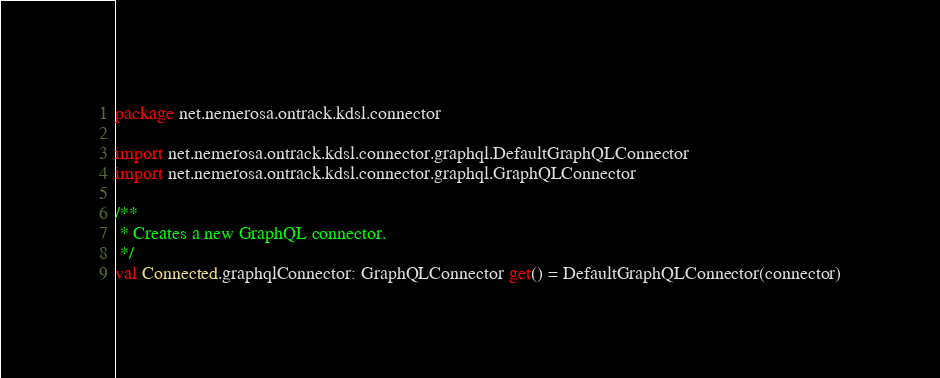Convert code to text. <code><loc_0><loc_0><loc_500><loc_500><_Kotlin_>package net.nemerosa.ontrack.kdsl.connector

import net.nemerosa.ontrack.kdsl.connector.graphql.DefaultGraphQLConnector
import net.nemerosa.ontrack.kdsl.connector.graphql.GraphQLConnector

/**
 * Creates a new GraphQL connector.
 */
val Connected.graphqlConnector: GraphQLConnector get() = DefaultGraphQLConnector(connector)</code> 